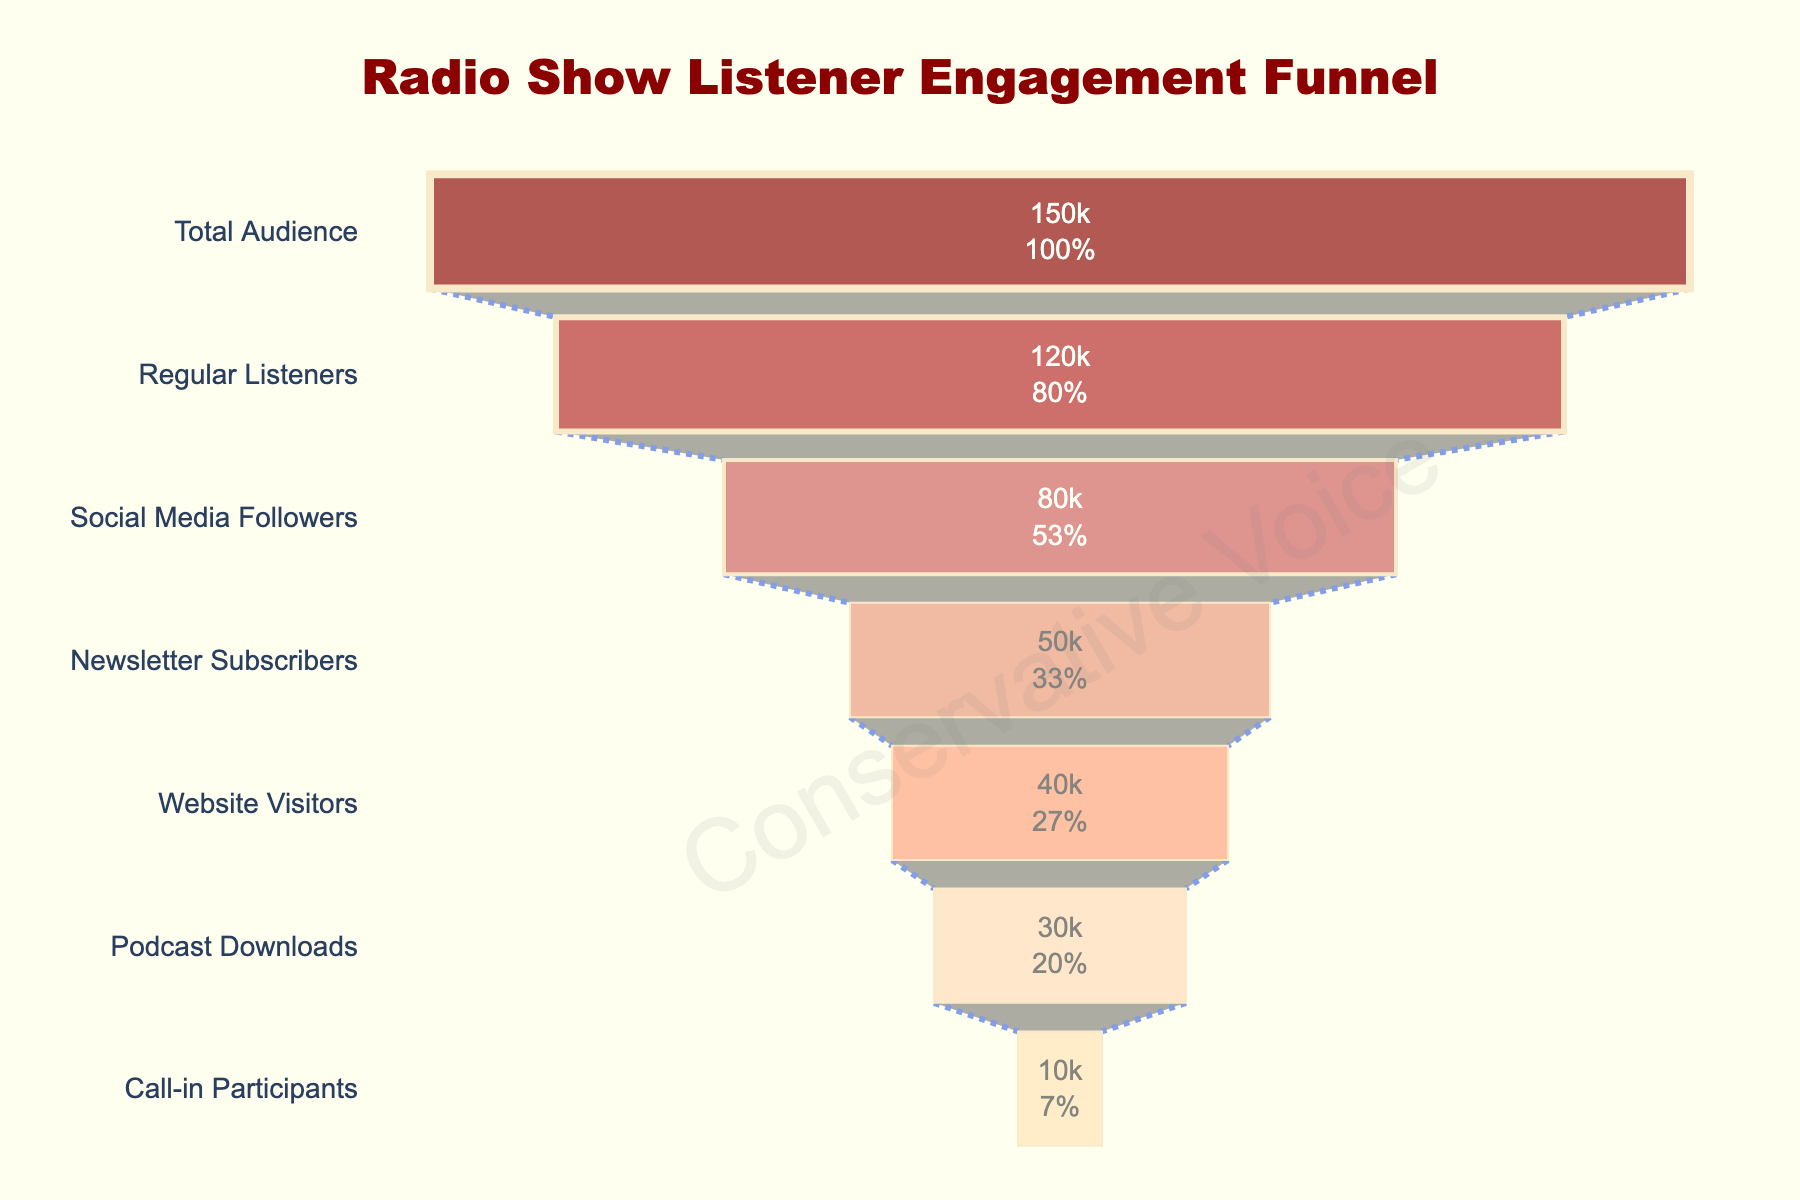What's the title of the funnel chart? The title is the most prominent text at the top of the chart, visually distinguishing the overall subject it represents. It reads "Radio Show Listener Engagement Funnel."
Answer: Radio Show Listener Engagement Funnel What is the total audience size? The total audience size is listed as the first data point in the funnel, marked as "Total Audience" at the top with the corresponding number.
Answer: 150,000 Which stage has the lowest number of participants? By scanning the funnel chart from top to bottom, the smallest value indicates the stage with the fewest participants, which is labeled as "Call-in Participants."
Answer: 10,000 How many more regular listeners are there compared to podcast downloads? Subtract the number of podcast downloads (30,000) from the number of regular listeners (120,000) to find the difference. 120,000 - 30,000 = 90,000
Answer: 90,000 What percentage of the total audience are social media followers? To calculate this, divide the number of social media followers (80,000) by the total audience (150,000) and multiply by 100. (80,000 / 150,000) * 100 = 53.33%
Answer: 53.33% Which stage follows "Newsletter Subscribers"? Observing the order presented in the funnel, "Website Visitors" is immediately below "Newsletter Subscribers."
Answer: Website Visitors What is the combined total of website visitors and call-in participants? By adding the number of website visitors (40,000) and call-in participants (10,000), we find the combined total. 40,000 + 10,000 = 50,000
Answer: 50,000 How does the number of regular listeners compare to the number of social media followers? Comparing these stages, regular listeners (120,000) are more than social media followers (80,000).
Answer: More How many stages have more than 50,000 listeners? Count the stages that record more than 50,000 listeners. These are 'Total Audience,' 'Regular Listeners,' and 'Social Media Followers.' There are three such stages.
Answer: 3 What is the drop-off from total audience to call-in participants? Subtracting the number of call-in participants (10,000) from the total audience (150,000) reveals the drop-off. 150,000 - 10,000 = 140,000
Answer: 140,000 